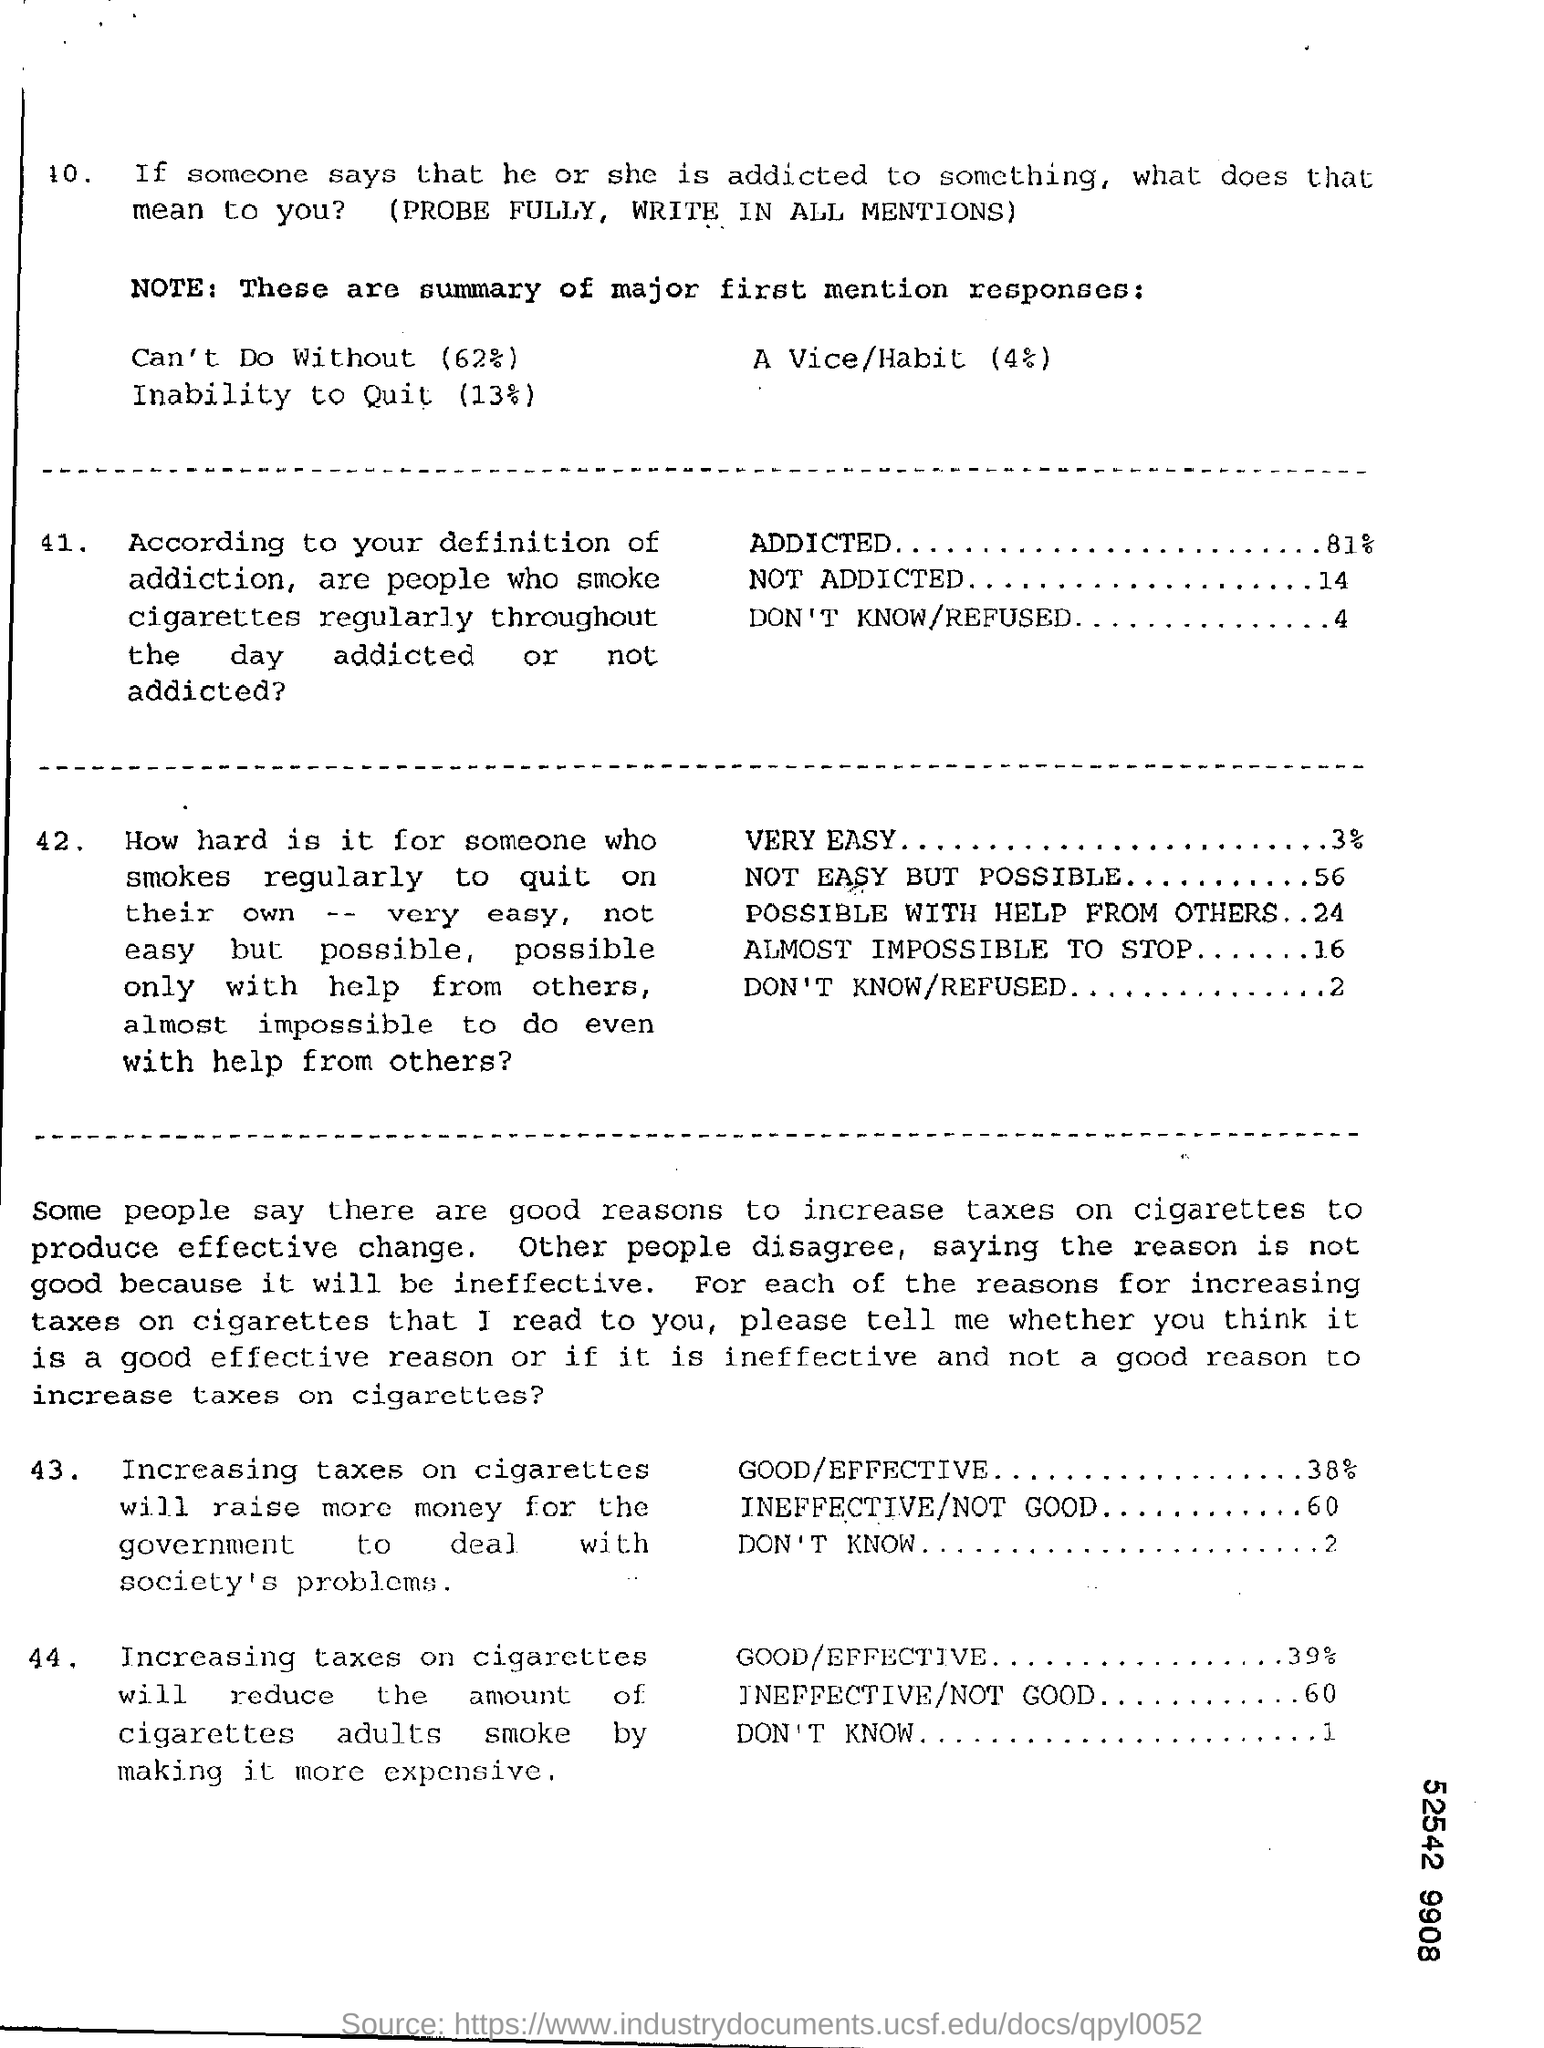How many percentage of people respond that people who smoke cigarrettes regularly throughout the day are Addicted?
Provide a succinct answer. 81%. How many percentage of people respond that people who smoke cigarrettes regularly throughout the day are Not Addicted?
Provide a short and direct response. 14. How many percentage of people respond that people who smoke cigarrettes regularly throughout the day are "Dont know/Refused"??
Your answer should be compact. 4. How many percentage of people respond that Increasing taxes on cigarettes will raise more money for the government to deal with society's problems is Good/Effective?
Your response must be concise. 38%. How many percentage of people respond that Increasing taxes on cigarettes will raise more money for the government to deal with society's problems is Ineffective/Not good?
Give a very brief answer. 60. How many percentage of people respond that Increasing taxes on cigarettes will raise more money for the government to deal with society's problems is "Dont Know"?
Make the answer very short. 2. 